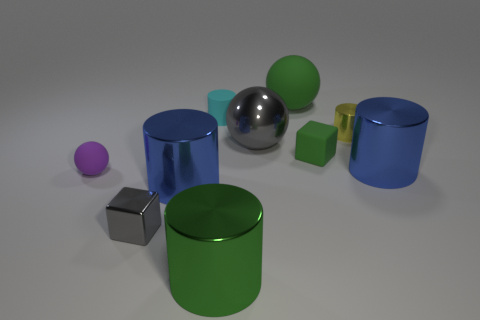Are there any shapes that repeat in the scene, and if so, which ones? Yes, there are repeating shapes in the scene. Cylinders and cubes are the two shapes that repeat, with each appearing in various sizes and colors. 